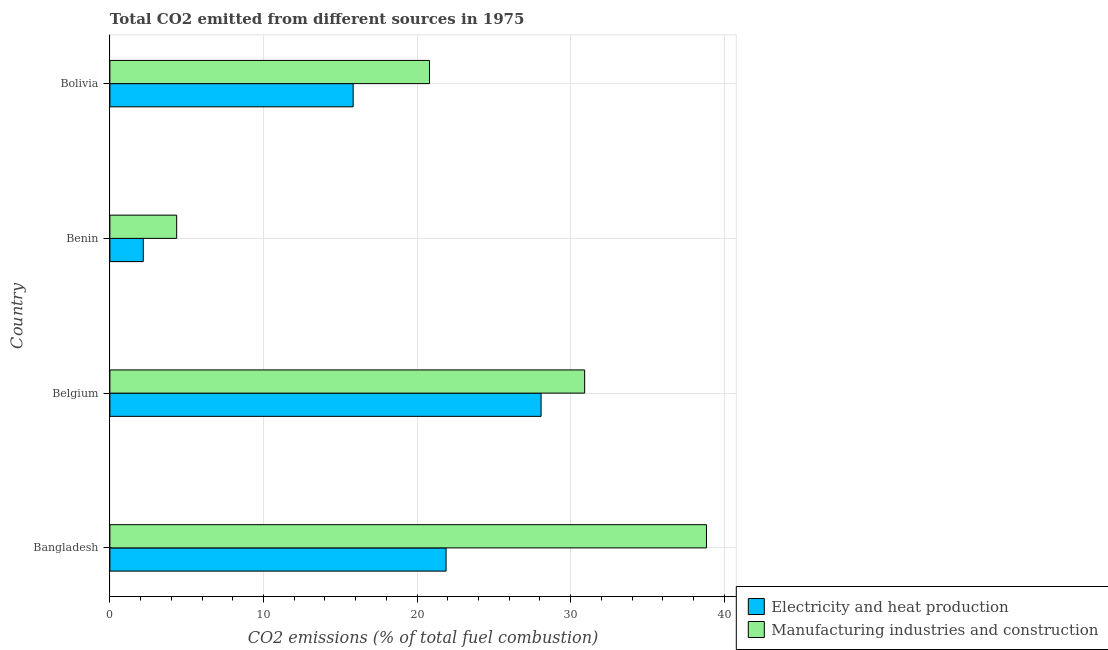How many bars are there on the 2nd tick from the top?
Provide a short and direct response. 2. What is the label of the 3rd group of bars from the top?
Provide a short and direct response. Belgium. What is the co2 emissions due to manufacturing industries in Belgium?
Provide a short and direct response. 30.91. Across all countries, what is the maximum co2 emissions due to electricity and heat production?
Give a very brief answer. 28.07. Across all countries, what is the minimum co2 emissions due to electricity and heat production?
Keep it short and to the point. 2.17. In which country was the co2 emissions due to electricity and heat production minimum?
Your response must be concise. Benin. What is the total co2 emissions due to electricity and heat production in the graph?
Make the answer very short. 67.97. What is the difference between the co2 emissions due to manufacturing industries in Belgium and that in Benin?
Ensure brevity in your answer.  26.56. What is the difference between the co2 emissions due to electricity and heat production in Benin and the co2 emissions due to manufacturing industries in Belgium?
Ensure brevity in your answer.  -28.74. What is the average co2 emissions due to manufacturing industries per country?
Your answer should be very brief. 23.73. What is the difference between the co2 emissions due to manufacturing industries and co2 emissions due to electricity and heat production in Bolivia?
Keep it short and to the point. 4.97. What is the ratio of the co2 emissions due to electricity and heat production in Bangladesh to that in Belgium?
Provide a succinct answer. 0.78. Is the co2 emissions due to electricity and heat production in Belgium less than that in Benin?
Keep it short and to the point. No. What is the difference between the highest and the second highest co2 emissions due to electricity and heat production?
Keep it short and to the point. 6.18. What is the difference between the highest and the lowest co2 emissions due to manufacturing industries?
Give a very brief answer. 34.49. Is the sum of the co2 emissions due to electricity and heat production in Belgium and Benin greater than the maximum co2 emissions due to manufacturing industries across all countries?
Provide a succinct answer. No. What does the 1st bar from the top in Belgium represents?
Your answer should be very brief. Manufacturing industries and construction. What does the 1st bar from the bottom in Bangladesh represents?
Keep it short and to the point. Electricity and heat production. How many bars are there?
Your response must be concise. 8. How many countries are there in the graph?
Keep it short and to the point. 4. What is the difference between two consecutive major ticks on the X-axis?
Your response must be concise. 10. Does the graph contain grids?
Your response must be concise. Yes. Where does the legend appear in the graph?
Provide a succinct answer. Bottom right. How many legend labels are there?
Make the answer very short. 2. What is the title of the graph?
Keep it short and to the point. Total CO2 emitted from different sources in 1975. Does "ODA received" appear as one of the legend labels in the graph?
Provide a short and direct response. No. What is the label or title of the X-axis?
Your response must be concise. CO2 emissions (% of total fuel combustion). What is the CO2 emissions (% of total fuel combustion) of Electricity and heat production in Bangladesh?
Your answer should be compact. 21.89. What is the CO2 emissions (% of total fuel combustion) in Manufacturing industries and construction in Bangladesh?
Offer a very short reply. 38.84. What is the CO2 emissions (% of total fuel combustion) of Electricity and heat production in Belgium?
Your answer should be very brief. 28.07. What is the CO2 emissions (% of total fuel combustion) in Manufacturing industries and construction in Belgium?
Give a very brief answer. 30.91. What is the CO2 emissions (% of total fuel combustion) of Electricity and heat production in Benin?
Keep it short and to the point. 2.17. What is the CO2 emissions (% of total fuel combustion) in Manufacturing industries and construction in Benin?
Give a very brief answer. 4.35. What is the CO2 emissions (% of total fuel combustion) in Electricity and heat production in Bolivia?
Offer a terse response. 15.84. What is the CO2 emissions (% of total fuel combustion) in Manufacturing industries and construction in Bolivia?
Make the answer very short. 20.81. Across all countries, what is the maximum CO2 emissions (% of total fuel combustion) of Electricity and heat production?
Provide a short and direct response. 28.07. Across all countries, what is the maximum CO2 emissions (% of total fuel combustion) in Manufacturing industries and construction?
Give a very brief answer. 38.84. Across all countries, what is the minimum CO2 emissions (% of total fuel combustion) in Electricity and heat production?
Give a very brief answer. 2.17. Across all countries, what is the minimum CO2 emissions (% of total fuel combustion) in Manufacturing industries and construction?
Make the answer very short. 4.35. What is the total CO2 emissions (% of total fuel combustion) in Electricity and heat production in the graph?
Give a very brief answer. 67.97. What is the total CO2 emissions (% of total fuel combustion) in Manufacturing industries and construction in the graph?
Your answer should be very brief. 94.91. What is the difference between the CO2 emissions (% of total fuel combustion) in Electricity and heat production in Bangladesh and that in Belgium?
Give a very brief answer. -6.18. What is the difference between the CO2 emissions (% of total fuel combustion) in Manufacturing industries and construction in Bangladesh and that in Belgium?
Make the answer very short. 7.93. What is the difference between the CO2 emissions (% of total fuel combustion) in Electricity and heat production in Bangladesh and that in Benin?
Provide a short and direct response. 19.71. What is the difference between the CO2 emissions (% of total fuel combustion) in Manufacturing industries and construction in Bangladesh and that in Benin?
Make the answer very short. 34.49. What is the difference between the CO2 emissions (% of total fuel combustion) in Electricity and heat production in Bangladesh and that in Bolivia?
Provide a succinct answer. 6.05. What is the difference between the CO2 emissions (% of total fuel combustion) of Manufacturing industries and construction in Bangladesh and that in Bolivia?
Offer a very short reply. 18.03. What is the difference between the CO2 emissions (% of total fuel combustion) of Electricity and heat production in Belgium and that in Benin?
Offer a very short reply. 25.9. What is the difference between the CO2 emissions (% of total fuel combustion) of Manufacturing industries and construction in Belgium and that in Benin?
Keep it short and to the point. 26.56. What is the difference between the CO2 emissions (% of total fuel combustion) of Electricity and heat production in Belgium and that in Bolivia?
Offer a terse response. 12.23. What is the difference between the CO2 emissions (% of total fuel combustion) in Manufacturing industries and construction in Belgium and that in Bolivia?
Make the answer very short. 10.1. What is the difference between the CO2 emissions (% of total fuel combustion) in Electricity and heat production in Benin and that in Bolivia?
Make the answer very short. -13.66. What is the difference between the CO2 emissions (% of total fuel combustion) in Manufacturing industries and construction in Benin and that in Bolivia?
Ensure brevity in your answer.  -16.46. What is the difference between the CO2 emissions (% of total fuel combustion) in Electricity and heat production in Bangladesh and the CO2 emissions (% of total fuel combustion) in Manufacturing industries and construction in Belgium?
Make the answer very short. -9.02. What is the difference between the CO2 emissions (% of total fuel combustion) in Electricity and heat production in Bangladesh and the CO2 emissions (% of total fuel combustion) in Manufacturing industries and construction in Benin?
Offer a terse response. 17.54. What is the difference between the CO2 emissions (% of total fuel combustion) in Electricity and heat production in Bangladesh and the CO2 emissions (% of total fuel combustion) in Manufacturing industries and construction in Bolivia?
Your response must be concise. 1.08. What is the difference between the CO2 emissions (% of total fuel combustion) of Electricity and heat production in Belgium and the CO2 emissions (% of total fuel combustion) of Manufacturing industries and construction in Benin?
Make the answer very short. 23.73. What is the difference between the CO2 emissions (% of total fuel combustion) of Electricity and heat production in Belgium and the CO2 emissions (% of total fuel combustion) of Manufacturing industries and construction in Bolivia?
Make the answer very short. 7.27. What is the difference between the CO2 emissions (% of total fuel combustion) of Electricity and heat production in Benin and the CO2 emissions (% of total fuel combustion) of Manufacturing industries and construction in Bolivia?
Give a very brief answer. -18.63. What is the average CO2 emissions (% of total fuel combustion) in Electricity and heat production per country?
Offer a very short reply. 16.99. What is the average CO2 emissions (% of total fuel combustion) of Manufacturing industries and construction per country?
Offer a terse response. 23.73. What is the difference between the CO2 emissions (% of total fuel combustion) in Electricity and heat production and CO2 emissions (% of total fuel combustion) in Manufacturing industries and construction in Bangladesh?
Provide a succinct answer. -16.95. What is the difference between the CO2 emissions (% of total fuel combustion) in Electricity and heat production and CO2 emissions (% of total fuel combustion) in Manufacturing industries and construction in Belgium?
Your answer should be very brief. -2.84. What is the difference between the CO2 emissions (% of total fuel combustion) of Electricity and heat production and CO2 emissions (% of total fuel combustion) of Manufacturing industries and construction in Benin?
Your answer should be very brief. -2.17. What is the difference between the CO2 emissions (% of total fuel combustion) in Electricity and heat production and CO2 emissions (% of total fuel combustion) in Manufacturing industries and construction in Bolivia?
Offer a terse response. -4.97. What is the ratio of the CO2 emissions (% of total fuel combustion) of Electricity and heat production in Bangladesh to that in Belgium?
Give a very brief answer. 0.78. What is the ratio of the CO2 emissions (% of total fuel combustion) in Manufacturing industries and construction in Bangladesh to that in Belgium?
Your answer should be compact. 1.26. What is the ratio of the CO2 emissions (% of total fuel combustion) in Electricity and heat production in Bangladesh to that in Benin?
Offer a very short reply. 10.07. What is the ratio of the CO2 emissions (% of total fuel combustion) in Manufacturing industries and construction in Bangladesh to that in Benin?
Provide a short and direct response. 8.93. What is the ratio of the CO2 emissions (% of total fuel combustion) of Electricity and heat production in Bangladesh to that in Bolivia?
Your response must be concise. 1.38. What is the ratio of the CO2 emissions (% of total fuel combustion) in Manufacturing industries and construction in Bangladesh to that in Bolivia?
Offer a very short reply. 1.87. What is the ratio of the CO2 emissions (% of total fuel combustion) of Electricity and heat production in Belgium to that in Benin?
Your answer should be compact. 12.91. What is the ratio of the CO2 emissions (% of total fuel combustion) in Manufacturing industries and construction in Belgium to that in Benin?
Provide a succinct answer. 7.11. What is the ratio of the CO2 emissions (% of total fuel combustion) in Electricity and heat production in Belgium to that in Bolivia?
Provide a short and direct response. 1.77. What is the ratio of the CO2 emissions (% of total fuel combustion) in Manufacturing industries and construction in Belgium to that in Bolivia?
Provide a short and direct response. 1.49. What is the ratio of the CO2 emissions (% of total fuel combustion) in Electricity and heat production in Benin to that in Bolivia?
Give a very brief answer. 0.14. What is the ratio of the CO2 emissions (% of total fuel combustion) of Manufacturing industries and construction in Benin to that in Bolivia?
Offer a very short reply. 0.21. What is the difference between the highest and the second highest CO2 emissions (% of total fuel combustion) in Electricity and heat production?
Provide a succinct answer. 6.18. What is the difference between the highest and the second highest CO2 emissions (% of total fuel combustion) in Manufacturing industries and construction?
Your answer should be compact. 7.93. What is the difference between the highest and the lowest CO2 emissions (% of total fuel combustion) in Electricity and heat production?
Give a very brief answer. 25.9. What is the difference between the highest and the lowest CO2 emissions (% of total fuel combustion) of Manufacturing industries and construction?
Your answer should be compact. 34.49. 